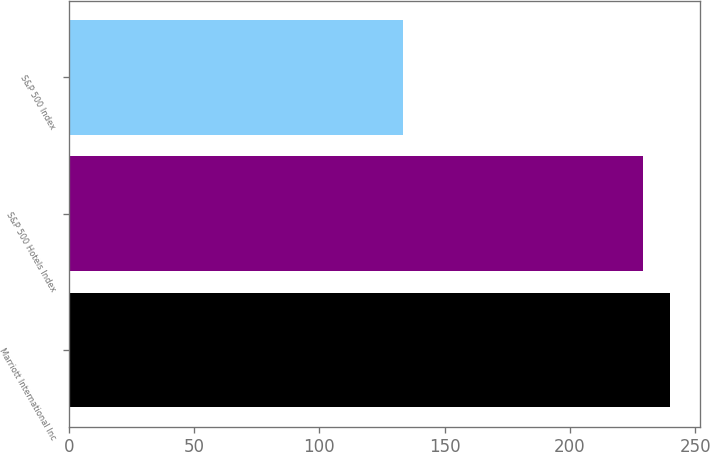Convert chart. <chart><loc_0><loc_0><loc_500><loc_500><bar_chart><fcel>Marriott International Inc<fcel>S&P 500 Hotels Index<fcel>S&P 500 Index<nl><fcel>240<fcel>229.1<fcel>133.5<nl></chart> 